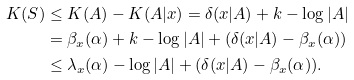Convert formula to latex. <formula><loc_0><loc_0><loc_500><loc_500>K ( S ) & \leq K ( A ) - K ( A | x ) = \delta ( x | A ) + k - \log | A | \\ & = \beta _ { x } ( \alpha ) + k - \log | A | + ( \delta ( x | A ) - \beta _ { x } ( \alpha ) ) \\ & \leq \lambda _ { x } ( \alpha ) - \log | A | + ( \delta ( x | A ) - \beta _ { x } ( \alpha ) ) .</formula> 